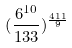Convert formula to latex. <formula><loc_0><loc_0><loc_500><loc_500>( \frac { 6 ^ { 1 0 } } { 1 3 3 } ) ^ { \frac { 4 1 1 } { 9 } }</formula> 